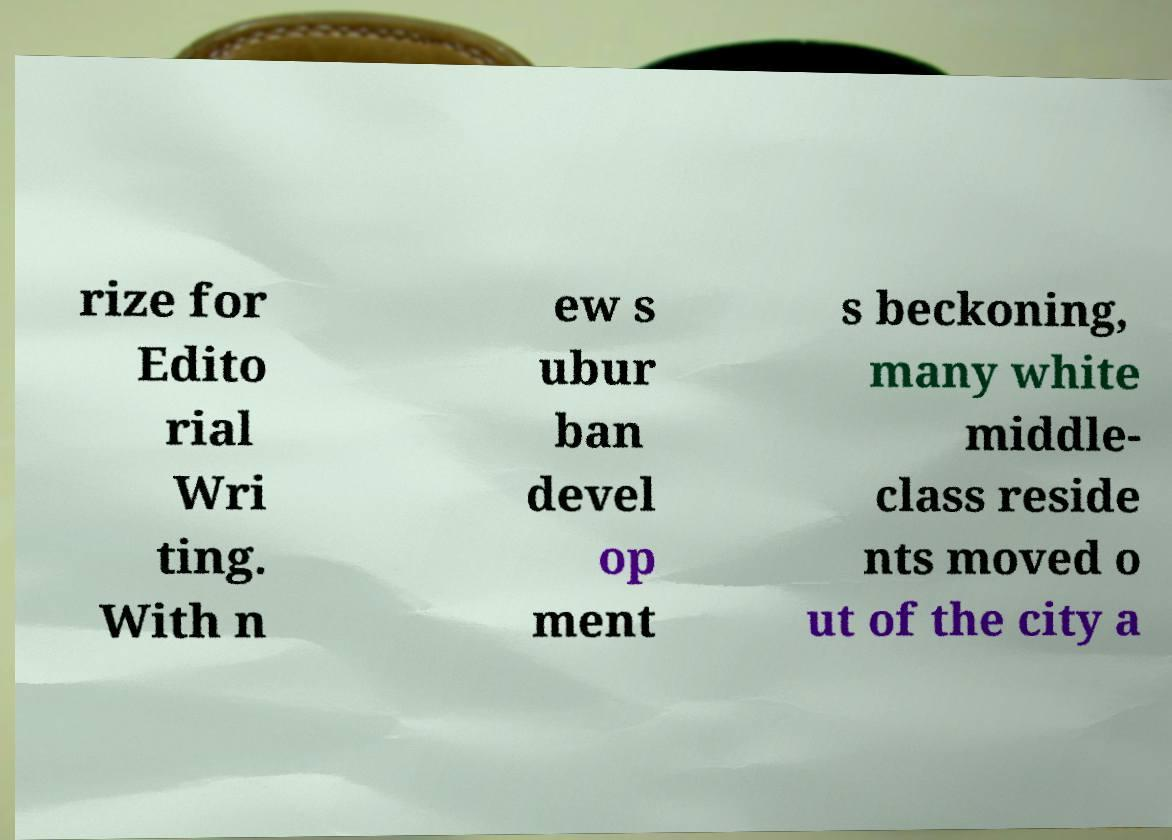Can you read and provide the text displayed in the image?This photo seems to have some interesting text. Can you extract and type it out for me? rize for Edito rial Wri ting. With n ew s ubur ban devel op ment s beckoning, many white middle- class reside nts moved o ut of the city a 